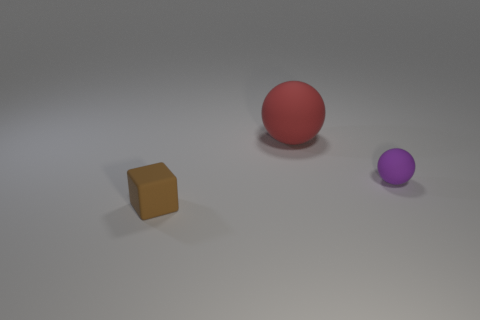The red ball that is made of the same material as the cube is what size?
Make the answer very short. Large. Do the brown cube and the rubber ball that is to the right of the large red sphere have the same size?
Offer a terse response. Yes. There is a small rubber object that is in front of the thing that is right of the red sphere; how many purple objects are to the right of it?
Offer a terse response. 1. Are there any brown objects in front of the large matte thing?
Keep it short and to the point. Yes. There is a big red matte thing; what shape is it?
Ensure brevity in your answer.  Sphere. What shape is the object to the left of the thing behind the small rubber object that is behind the brown cube?
Make the answer very short. Cube. How many other objects are there of the same shape as the tiny brown thing?
Provide a succinct answer. 0. Is there anything else that has the same size as the purple matte ball?
Keep it short and to the point. Yes. What is the color of the sphere to the left of the small object that is on the right side of the tiny brown rubber thing?
Provide a succinct answer. Red. Is the number of large spheres less than the number of yellow objects?
Make the answer very short. No. 